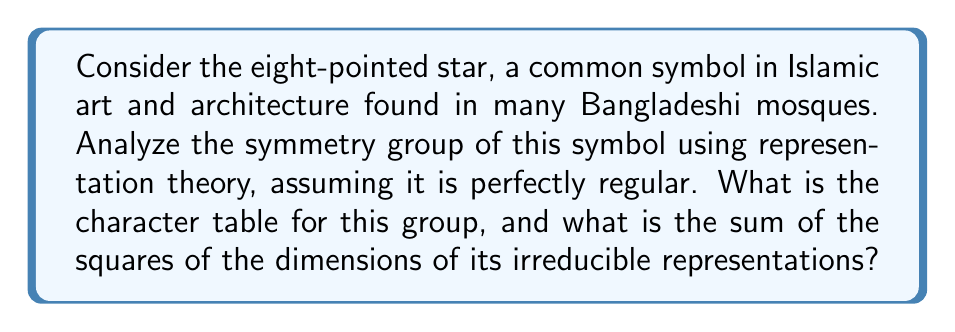Give your solution to this math problem. Let's approach this step-by-step:

1) The symmetry group of a regular eight-pointed star is the dihedral group $D_8$, which has 16 elements: 8 rotations and 8 reflections.

2) $D_8$ has 5 conjugacy classes:
   - $e$ (identity)
   - $r^4$ (rotation by 180°)
   - $\{r, r^7\}$ (rotations by 45° and 315°)
   - $\{r^2, r^6\}$ (rotations by 90° and 270°)
   - $\{r^3, r^5\}$ (rotations by 135° and 225°)
   - $\{s, sr, sr^2, sr^3, sr^4, sr^5, sr^6, sr^7\}$ (8 reflections)

3) $D_8$ has 5 irreducible representations:
   - Two 1-dimensional representations: trivial ($\chi_1$) and sign ($\chi_2$)
   - Three 2-dimensional representations ($\chi_3$, $\chi_4$, $\chi_5$)

4) The character table for $D_8$ is:

$$
\begin{array}{c|ccccc}
D_8 & e & r^4 & \{r,r^7\} & \{r^2,r^6\} & \{r^3,r^5\} & \{s,sr,sr^2,sr^3,sr^4,sr^5,sr^6,sr^7\} \\
\hline
\chi_1 & 1 & 1 & 1 & 1 & 1 & 1 \\
\chi_2 & 1 & 1 & 1 & 1 & 1 & -1 \\
\chi_3 & 2 & 2 & \sqrt{2} & 0 & -\sqrt{2} & 0 \\
\chi_4 & 2 & 2 & -\sqrt{2} & 0 & \sqrt{2} & 0 \\
\chi_5 & 2 & -2 & 0 & 0 & 0 & 0
\end{array}
$$

5) To find the sum of the squares of the dimensions of irreducible representations:
   $1^2 + 1^2 + 2^2 + 2^2 + 2^2 = 1 + 1 + 4 + 4 + 4 = 14$

6) We can verify this using the order of the group:
   $|D_8| = 16 = 1^2 + 1^2 + 2^2 + 2^2 + 2^2 = 14$
Answer: 14 